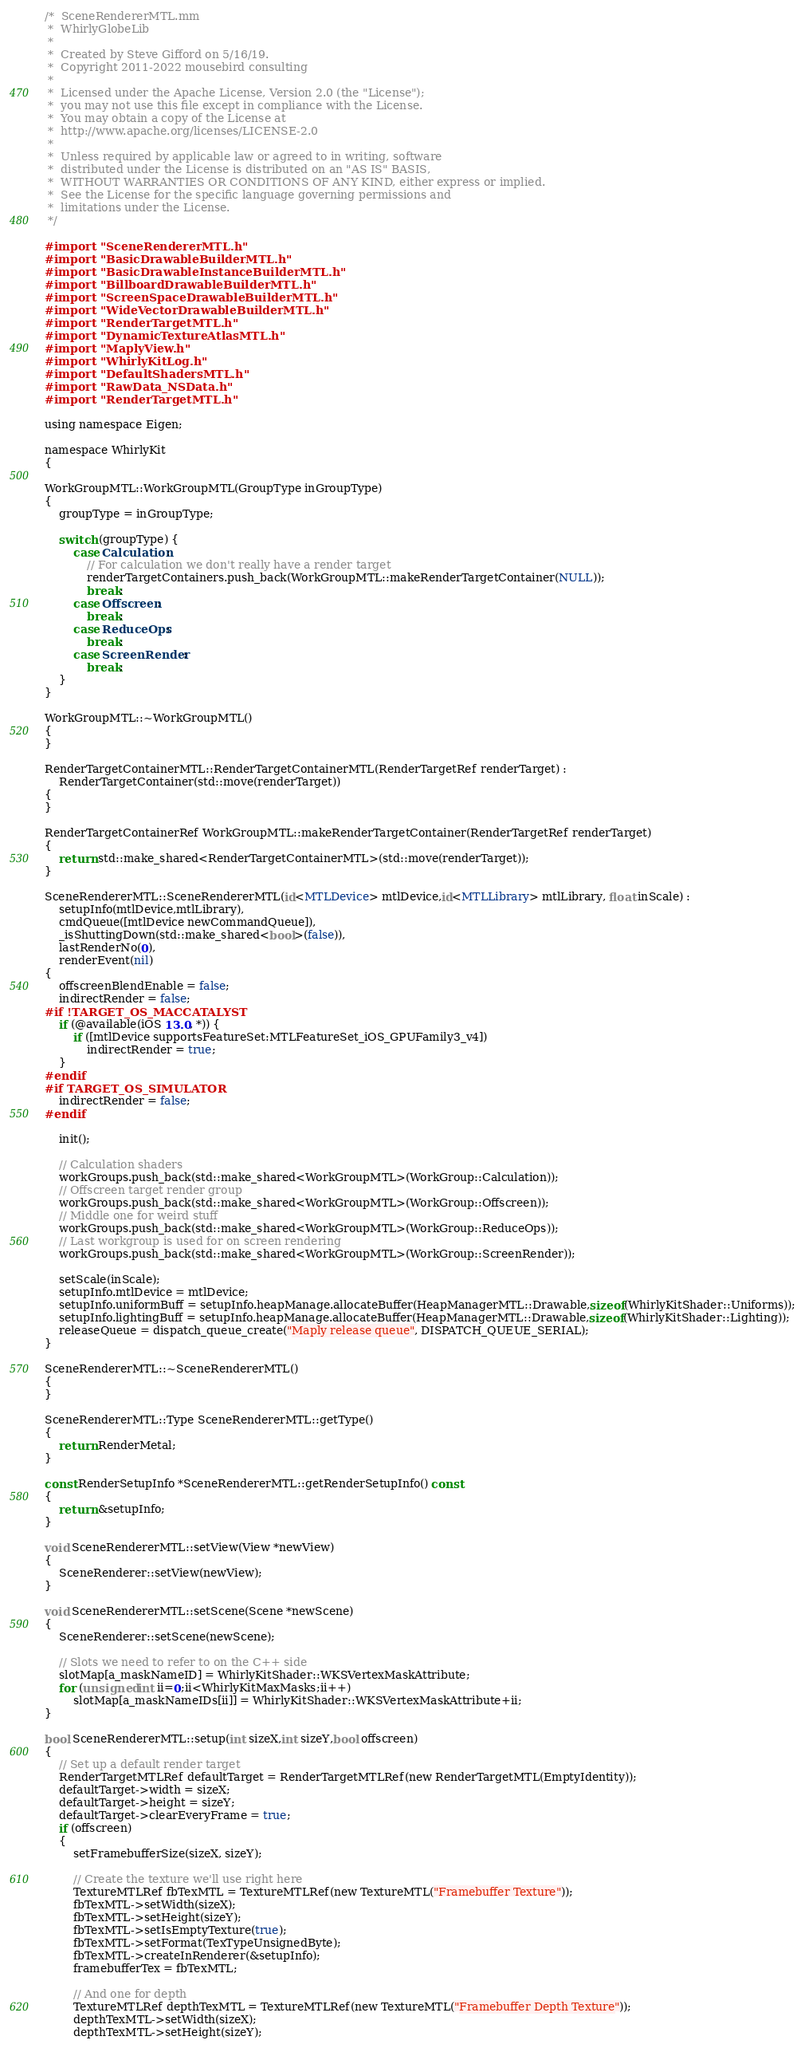<code> <loc_0><loc_0><loc_500><loc_500><_ObjectiveC_>/*  SceneRendererMTL.mm
 *  WhirlyGlobeLib
 *
 *  Created by Steve Gifford on 5/16/19.
 *  Copyright 2011-2022 mousebird consulting
 *
 *  Licensed under the Apache License, Version 2.0 (the "License");
 *  you may not use this file except in compliance with the License.
 *  You may obtain a copy of the License at
 *  http://www.apache.org/licenses/LICENSE-2.0
 *
 *  Unless required by applicable law or agreed to in writing, software
 *  distributed under the License is distributed on an "AS IS" BASIS,
 *  WITHOUT WARRANTIES OR CONDITIONS OF ANY KIND, either express or implied.
 *  See the License for the specific language governing permissions and
 *  limitations under the License.
 */

#import "SceneRendererMTL.h"
#import "BasicDrawableBuilderMTL.h"
#import "BasicDrawableInstanceBuilderMTL.h"
#import "BillboardDrawableBuilderMTL.h"
#import "ScreenSpaceDrawableBuilderMTL.h"
#import "WideVectorDrawableBuilderMTL.h"
#import "RenderTargetMTL.h"
#import "DynamicTextureAtlasMTL.h"
#import "MaplyView.h"
#import "WhirlyKitLog.h"
#import "DefaultShadersMTL.h"
#import "RawData_NSData.h"
#import "RenderTargetMTL.h"

using namespace Eigen;

namespace WhirlyKit
{

WorkGroupMTL::WorkGroupMTL(GroupType inGroupType)
{
    groupType = inGroupType;
    
    switch (groupType) {
        case Calculation:
            // For calculation we don't really have a render target
            renderTargetContainers.push_back(WorkGroupMTL::makeRenderTargetContainer(NULL));
            break;
        case Offscreen:
            break;
        case ReduceOps:
            break;
        case ScreenRender:
            break;
    }
}

WorkGroupMTL::~WorkGroupMTL()
{
}

RenderTargetContainerMTL::RenderTargetContainerMTL(RenderTargetRef renderTarget) :
    RenderTargetContainer(std::move(renderTarget))
{
}

RenderTargetContainerRef WorkGroupMTL::makeRenderTargetContainer(RenderTargetRef renderTarget)
{
    return std::make_shared<RenderTargetContainerMTL>(std::move(renderTarget));
}

SceneRendererMTL::SceneRendererMTL(id<MTLDevice> mtlDevice,id<MTLLibrary> mtlLibrary, float inScale) :
    setupInfo(mtlDevice,mtlLibrary),
    cmdQueue([mtlDevice newCommandQueue]),
    _isShuttingDown(std::make_shared<bool>(false)),
    lastRenderNo(0),
    renderEvent(nil)
{
    offscreenBlendEnable = false;
    indirectRender = false;
#if !TARGET_OS_MACCATALYST
    if (@available(iOS 13.0, *)) {
        if ([mtlDevice supportsFeatureSet:MTLFeatureSet_iOS_GPUFamily3_v4])
            indirectRender = true;
    }
#endif
#if TARGET_OS_SIMULATOR
    indirectRender = false;
#endif

    init();
        
    // Calculation shaders
    workGroups.push_back(std::make_shared<WorkGroupMTL>(WorkGroup::Calculation));
    // Offscreen target render group
    workGroups.push_back(std::make_shared<WorkGroupMTL>(WorkGroup::Offscreen));
    // Middle one for weird stuff
    workGroups.push_back(std::make_shared<WorkGroupMTL>(WorkGroup::ReduceOps));
    // Last workgroup is used for on screen rendering
    workGroups.push_back(std::make_shared<WorkGroupMTL>(WorkGroup::ScreenRender));

    setScale(inScale);
    setupInfo.mtlDevice = mtlDevice;
    setupInfo.uniformBuff = setupInfo.heapManage.allocateBuffer(HeapManagerMTL::Drawable,sizeof(WhirlyKitShader::Uniforms));
    setupInfo.lightingBuff = setupInfo.heapManage.allocateBuffer(HeapManagerMTL::Drawable,sizeof(WhirlyKitShader::Lighting));
    releaseQueue = dispatch_queue_create("Maply release queue", DISPATCH_QUEUE_SERIAL);
}
    
SceneRendererMTL::~SceneRendererMTL()
{
}

SceneRendererMTL::Type SceneRendererMTL::getType()
{
    return RenderMetal;
}

const RenderSetupInfo *SceneRendererMTL::getRenderSetupInfo() const
{
    return &setupInfo;
}

void SceneRendererMTL::setView(View *newView)
{
    SceneRenderer::setView(newView);
}

void SceneRendererMTL::setScene(Scene *newScene)
{
    SceneRenderer::setScene(newScene);
    
    // Slots we need to refer to on the C++ side
    slotMap[a_maskNameID] = WhirlyKitShader::WKSVertexMaskAttribute;
    for (unsigned int ii=0;ii<WhirlyKitMaxMasks;ii++)
        slotMap[a_maskNameIDs[ii]] = WhirlyKitShader::WKSVertexMaskAttribute+ii;
}

bool SceneRendererMTL::setup(int sizeX,int sizeY,bool offscreen)
{
    // Set up a default render target
    RenderTargetMTLRef defaultTarget = RenderTargetMTLRef(new RenderTargetMTL(EmptyIdentity));
    defaultTarget->width = sizeX;
    defaultTarget->height = sizeY;
    defaultTarget->clearEveryFrame = true;
    if (offscreen)
    {
        setFramebufferSize(sizeX, sizeY);
        
        // Create the texture we'll use right here
        TextureMTLRef fbTexMTL = TextureMTLRef(new TextureMTL("Framebuffer Texture"));
        fbTexMTL->setWidth(sizeX);
        fbTexMTL->setHeight(sizeY);
        fbTexMTL->setIsEmptyTexture(true);
        fbTexMTL->setFormat(TexTypeUnsignedByte);
        fbTexMTL->createInRenderer(&setupInfo);
        framebufferTex = fbTexMTL;
        
        // And one for depth
        TextureMTLRef depthTexMTL = TextureMTLRef(new TextureMTL("Framebuffer Depth Texture"));
        depthTexMTL->setWidth(sizeX);
        depthTexMTL->setHeight(sizeY);</code> 